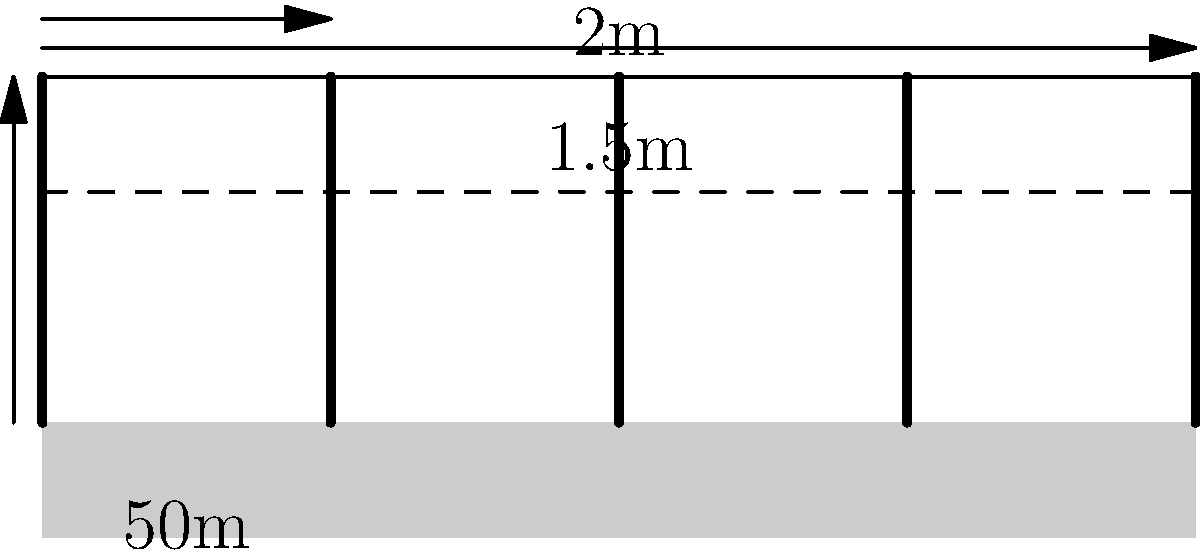A wildlife-friendly fence is being designed to protect crops while allowing safe passage for local animals. The fence consists of two wires: a top wire at 2m height and a lower wire at 1.5m height. If the total length of the fence is 1000m, and the optimal post spacing is 50m, how many fence posts are required, and what is the total length of wire needed for the fence? Let's approach this step-by-step:

1. Calculating the number of fence posts:
   - The total length of the fence is 1000m
   - The spacing between posts is 50m
   - Number of spaces = Total length / Spacing
   - Number of spaces = 1000m / 50m = 20
   - Number of posts = Number of spaces + 1 (we need an extra post at the end)
   - Number of posts = 20 + 1 = 21

2. Calculating the total length of wire:
   - We have two wires running the entire length of the fence
   - Length of each wire = Total length of the fence = 1000m
   - Total length of wire = 2 * 1000m = 2000m

Therefore, we need 21 fence posts and 2000m of wire.
Answer: 21 posts, 2000m wire 